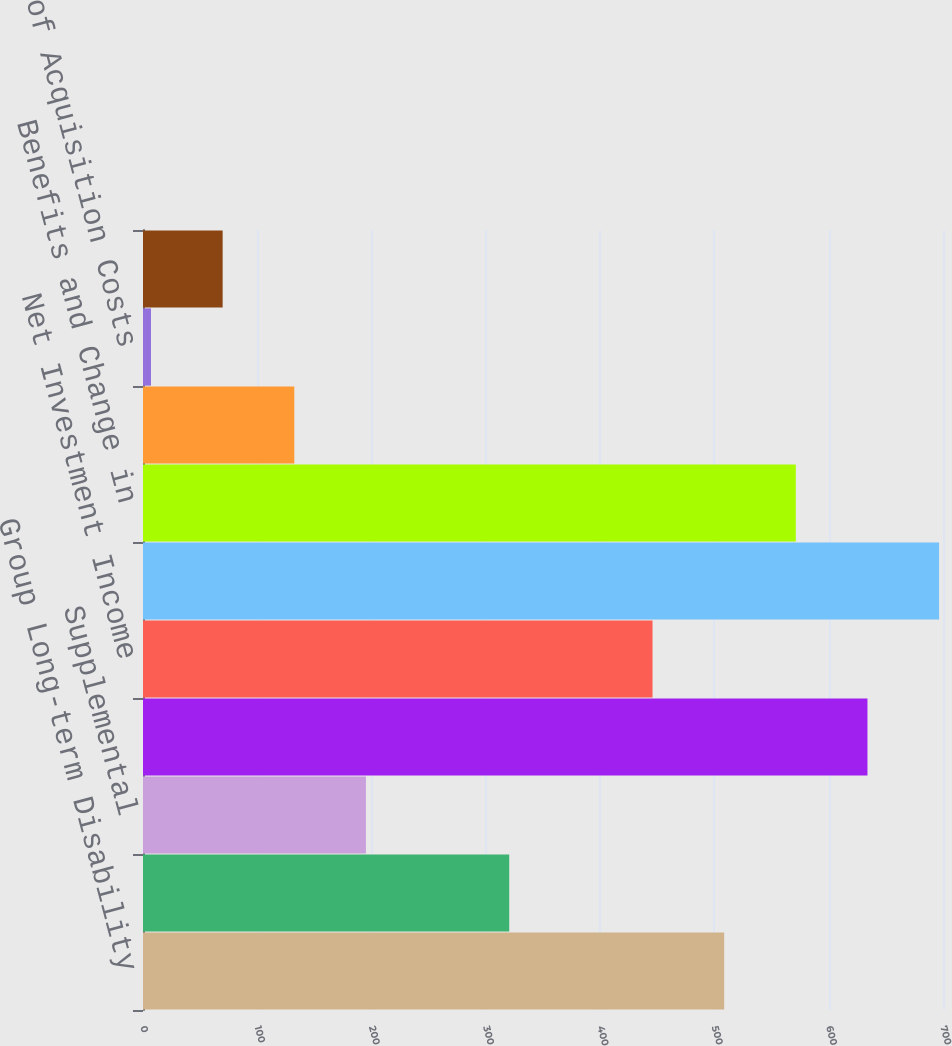<chart> <loc_0><loc_0><loc_500><loc_500><bar_chart><fcel>Group Long-term Disability<fcel>Group Life<fcel>Supplemental<fcel>Total Premium Income<fcel>Net Investment Income<fcel>Total<fcel>Benefits and Change in<fcel>Commissions<fcel>Deferral of Acquisition Costs<fcel>Amortization of Deferred<nl><fcel>508.52<fcel>320.45<fcel>195.07<fcel>633.9<fcel>445.83<fcel>696.59<fcel>571.21<fcel>132.38<fcel>7<fcel>69.69<nl></chart> 